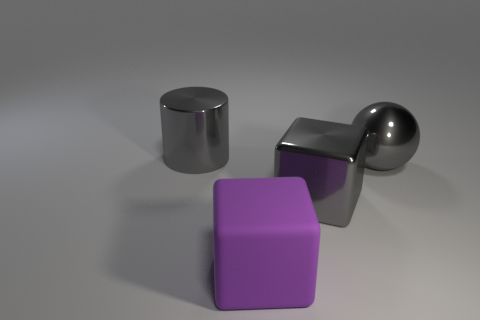Add 1 cyan rubber cylinders. How many objects exist? 5 Subtract all balls. How many objects are left? 3 Subtract 0 green cylinders. How many objects are left? 4 Subtract all blue matte cubes. Subtract all large gray metallic objects. How many objects are left? 1 Add 3 large metal cylinders. How many large metal cylinders are left? 4 Add 1 yellow matte objects. How many yellow matte objects exist? 1 